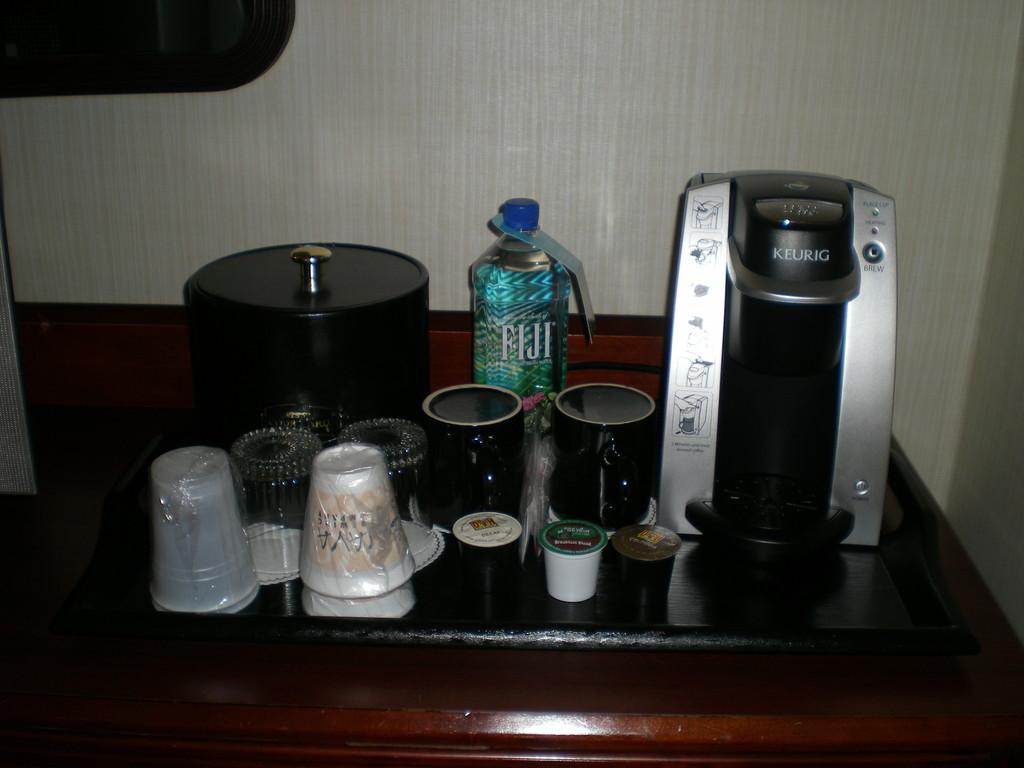<image>
Write a terse but informative summary of the picture. A coffee maker from KEURIG, water bottle, cups and ice bucket on a counter. 